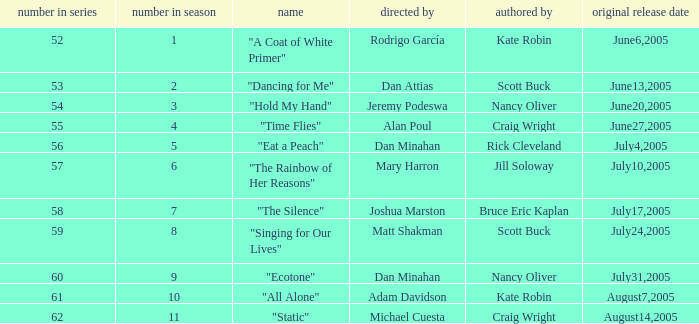What s the episode number in the season that was written by Nancy Oliver? 9.0. 